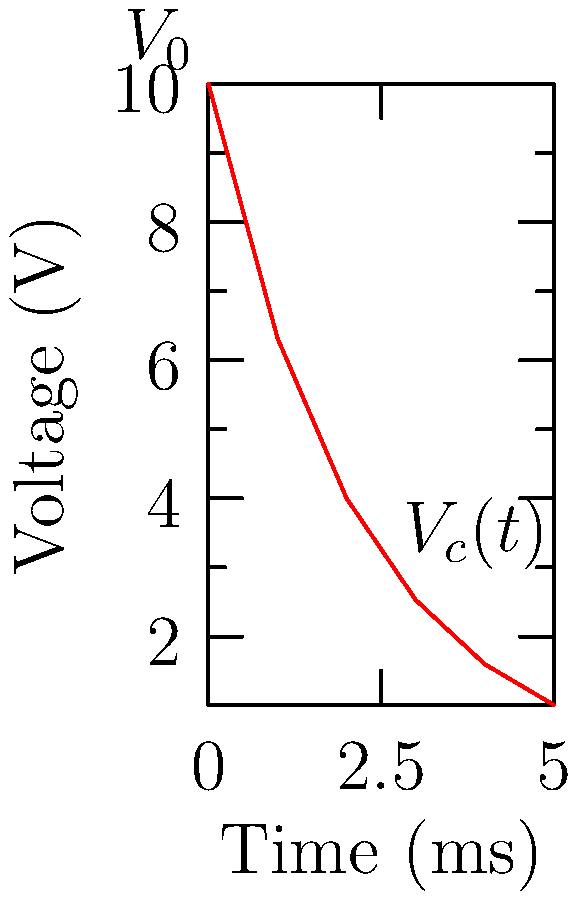Given the voltage-time graph of a discharging RC circuit, estimate the time constant $\tau$ of the circuit. Assume the initial voltage $V_0$ is 10V. To estimate the time constant $\tau$ of an RC circuit, we can use the voltage decay equation:

$$V_c(t) = V_0 e^{-t/\tau}$$

Where $V_c(t)$ is the capacitor voltage at time $t$, $V_0$ is the initial voltage, and $\tau$ is the time constant.

The time constant $\tau$ is the time it takes for the voltage to decay to approximately 36.8% of its initial value. This is because:

$$e^{-1} \approx 0.368$$

From the graph, we can see that:
1. The initial voltage $V_0 = 10V$
2. We need to find the time when $V_c(t) \approx 0.368 \times 10V = 3.68V$

Looking at the graph, we can estimate that the voltage reaches approximately 3.68V between 2 and 3 ms.

By linear interpolation between the points (2ms, 4V) and (3ms, 2.53V), we can estimate more precisely:

$$t \approx 2 + \frac{4 - 3.68}{4 - 2.53} = 2 + 0.22 = 2.22 \text{ ms}$$

Therefore, the estimated time constant $\tau$ is approximately 2.22 ms.
Answer: $\tau \approx 2.22 \text{ ms}$ 